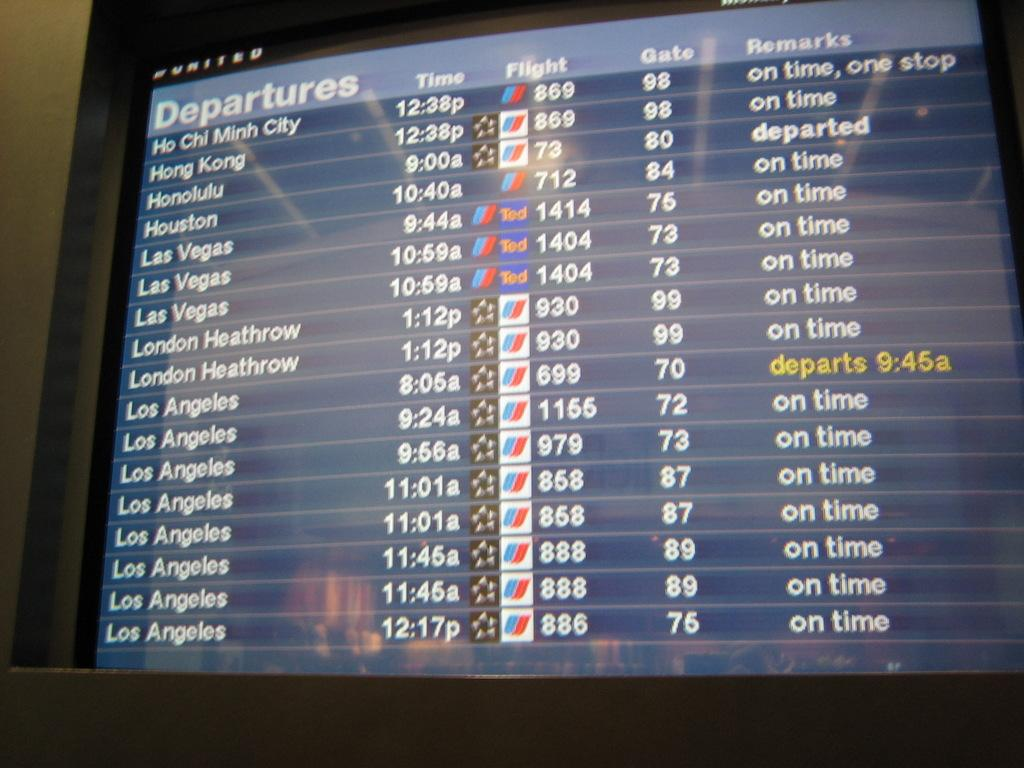<image>
Render a clear and concise summary of the photo. A television display shows the departure times for flights. 